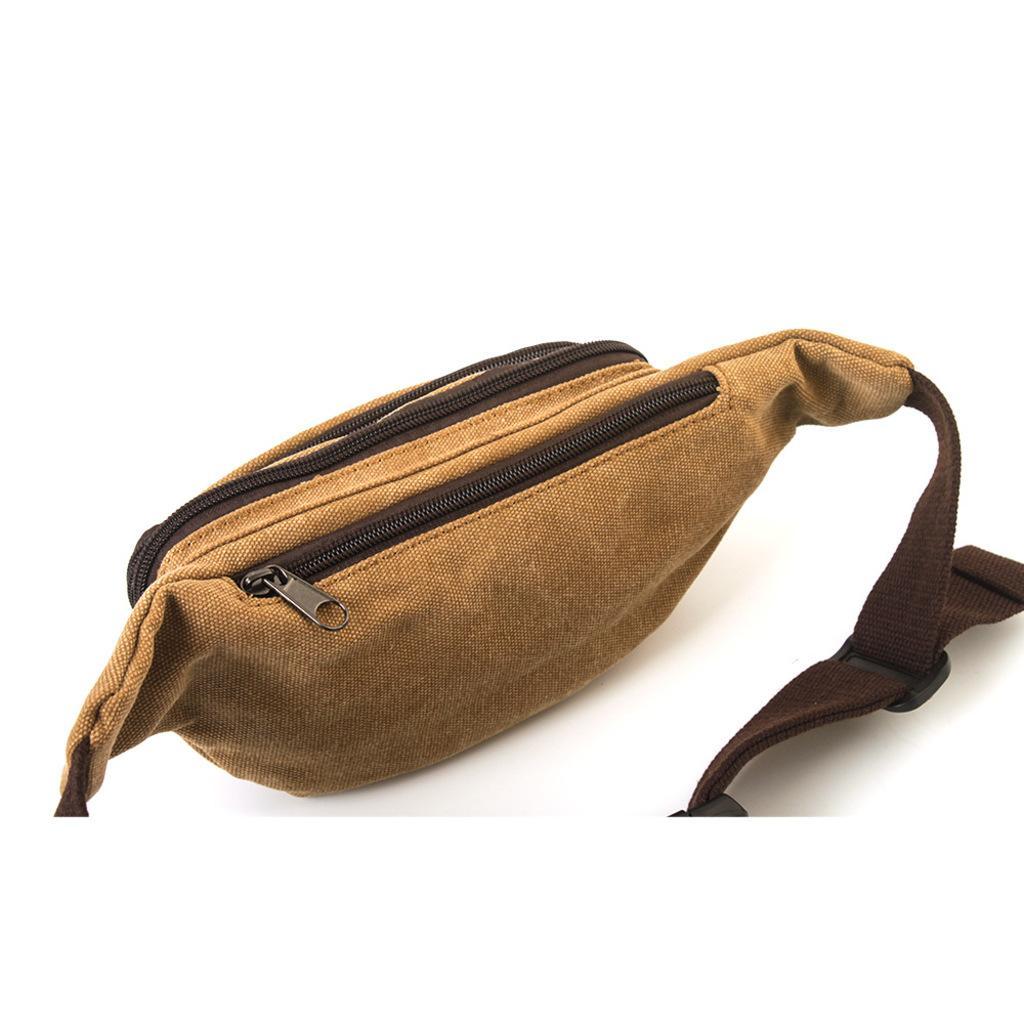Please provide a concise description of this image. This picture shows a waist bag. it is brown in colour and we can see two zipś to it 